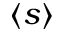Convert formula to latex. <formula><loc_0><loc_0><loc_500><loc_500>\langle s \rangle</formula> 